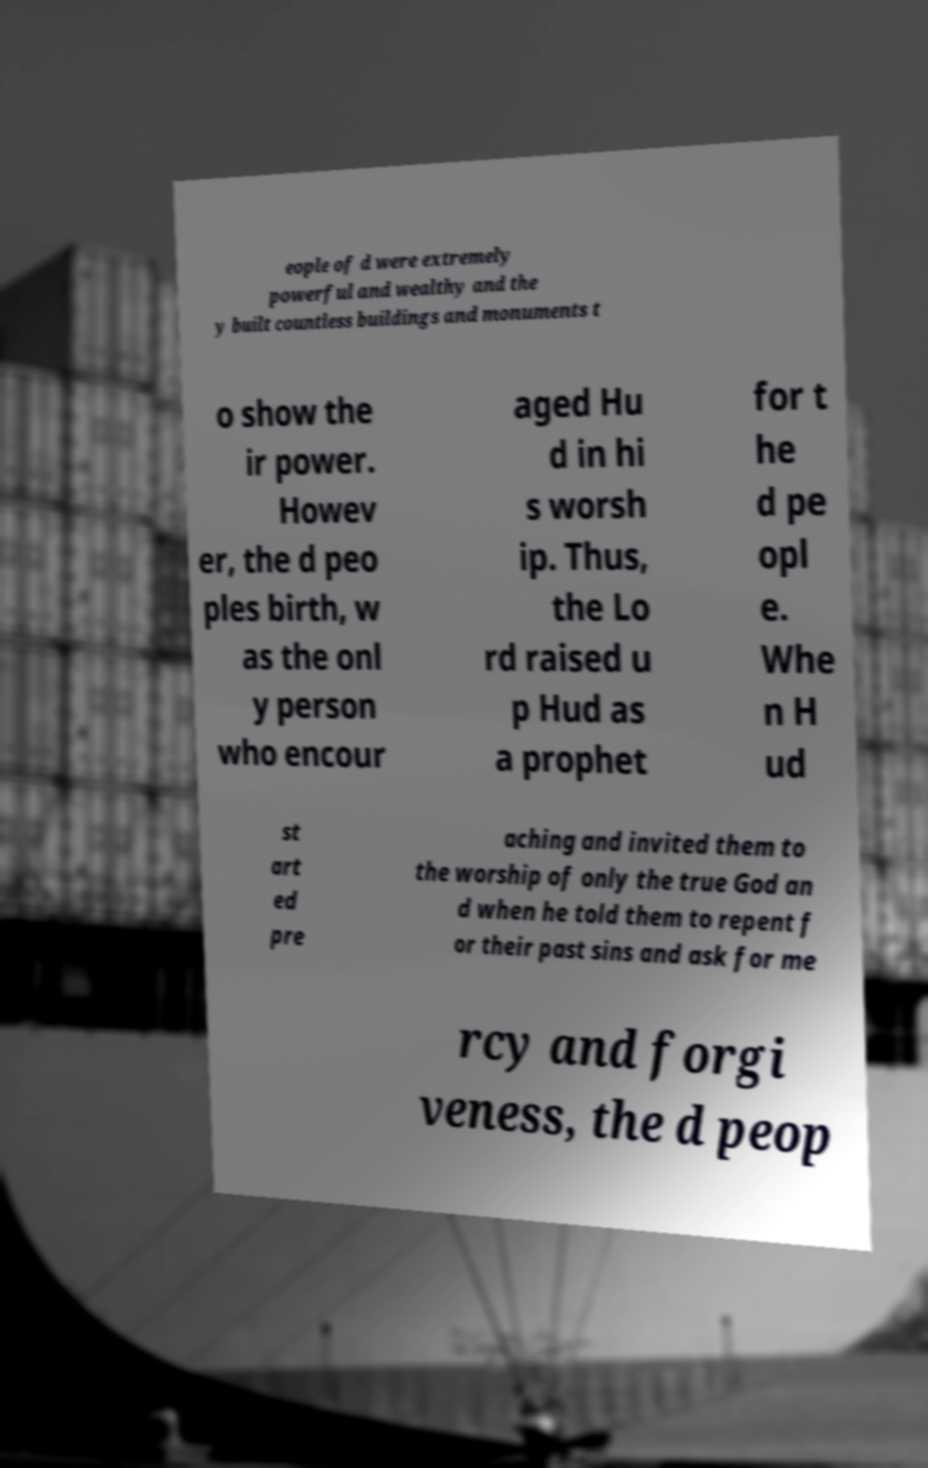What messages or text are displayed in this image? I need them in a readable, typed format. eople of d were extremely powerful and wealthy and the y built countless buildings and monuments t o show the ir power. Howev er, the d peo ples birth, w as the onl y person who encour aged Hu d in hi s worsh ip. Thus, the Lo rd raised u p Hud as a prophet for t he d pe opl e. Whe n H ud st art ed pre aching and invited them to the worship of only the true God an d when he told them to repent f or their past sins and ask for me rcy and forgi veness, the d peop 